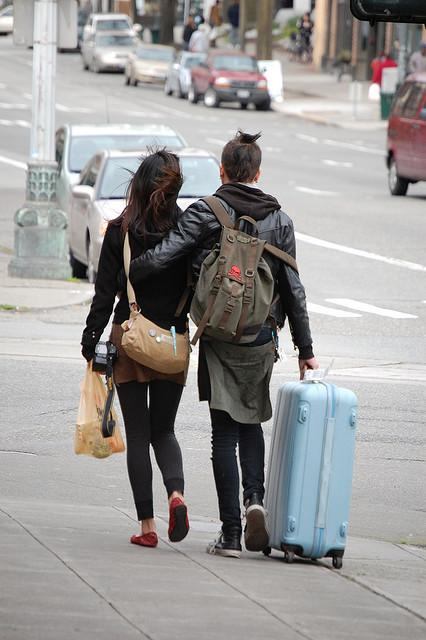What type of parking is available? Please explain your reasoning. street. There is street parking available. 